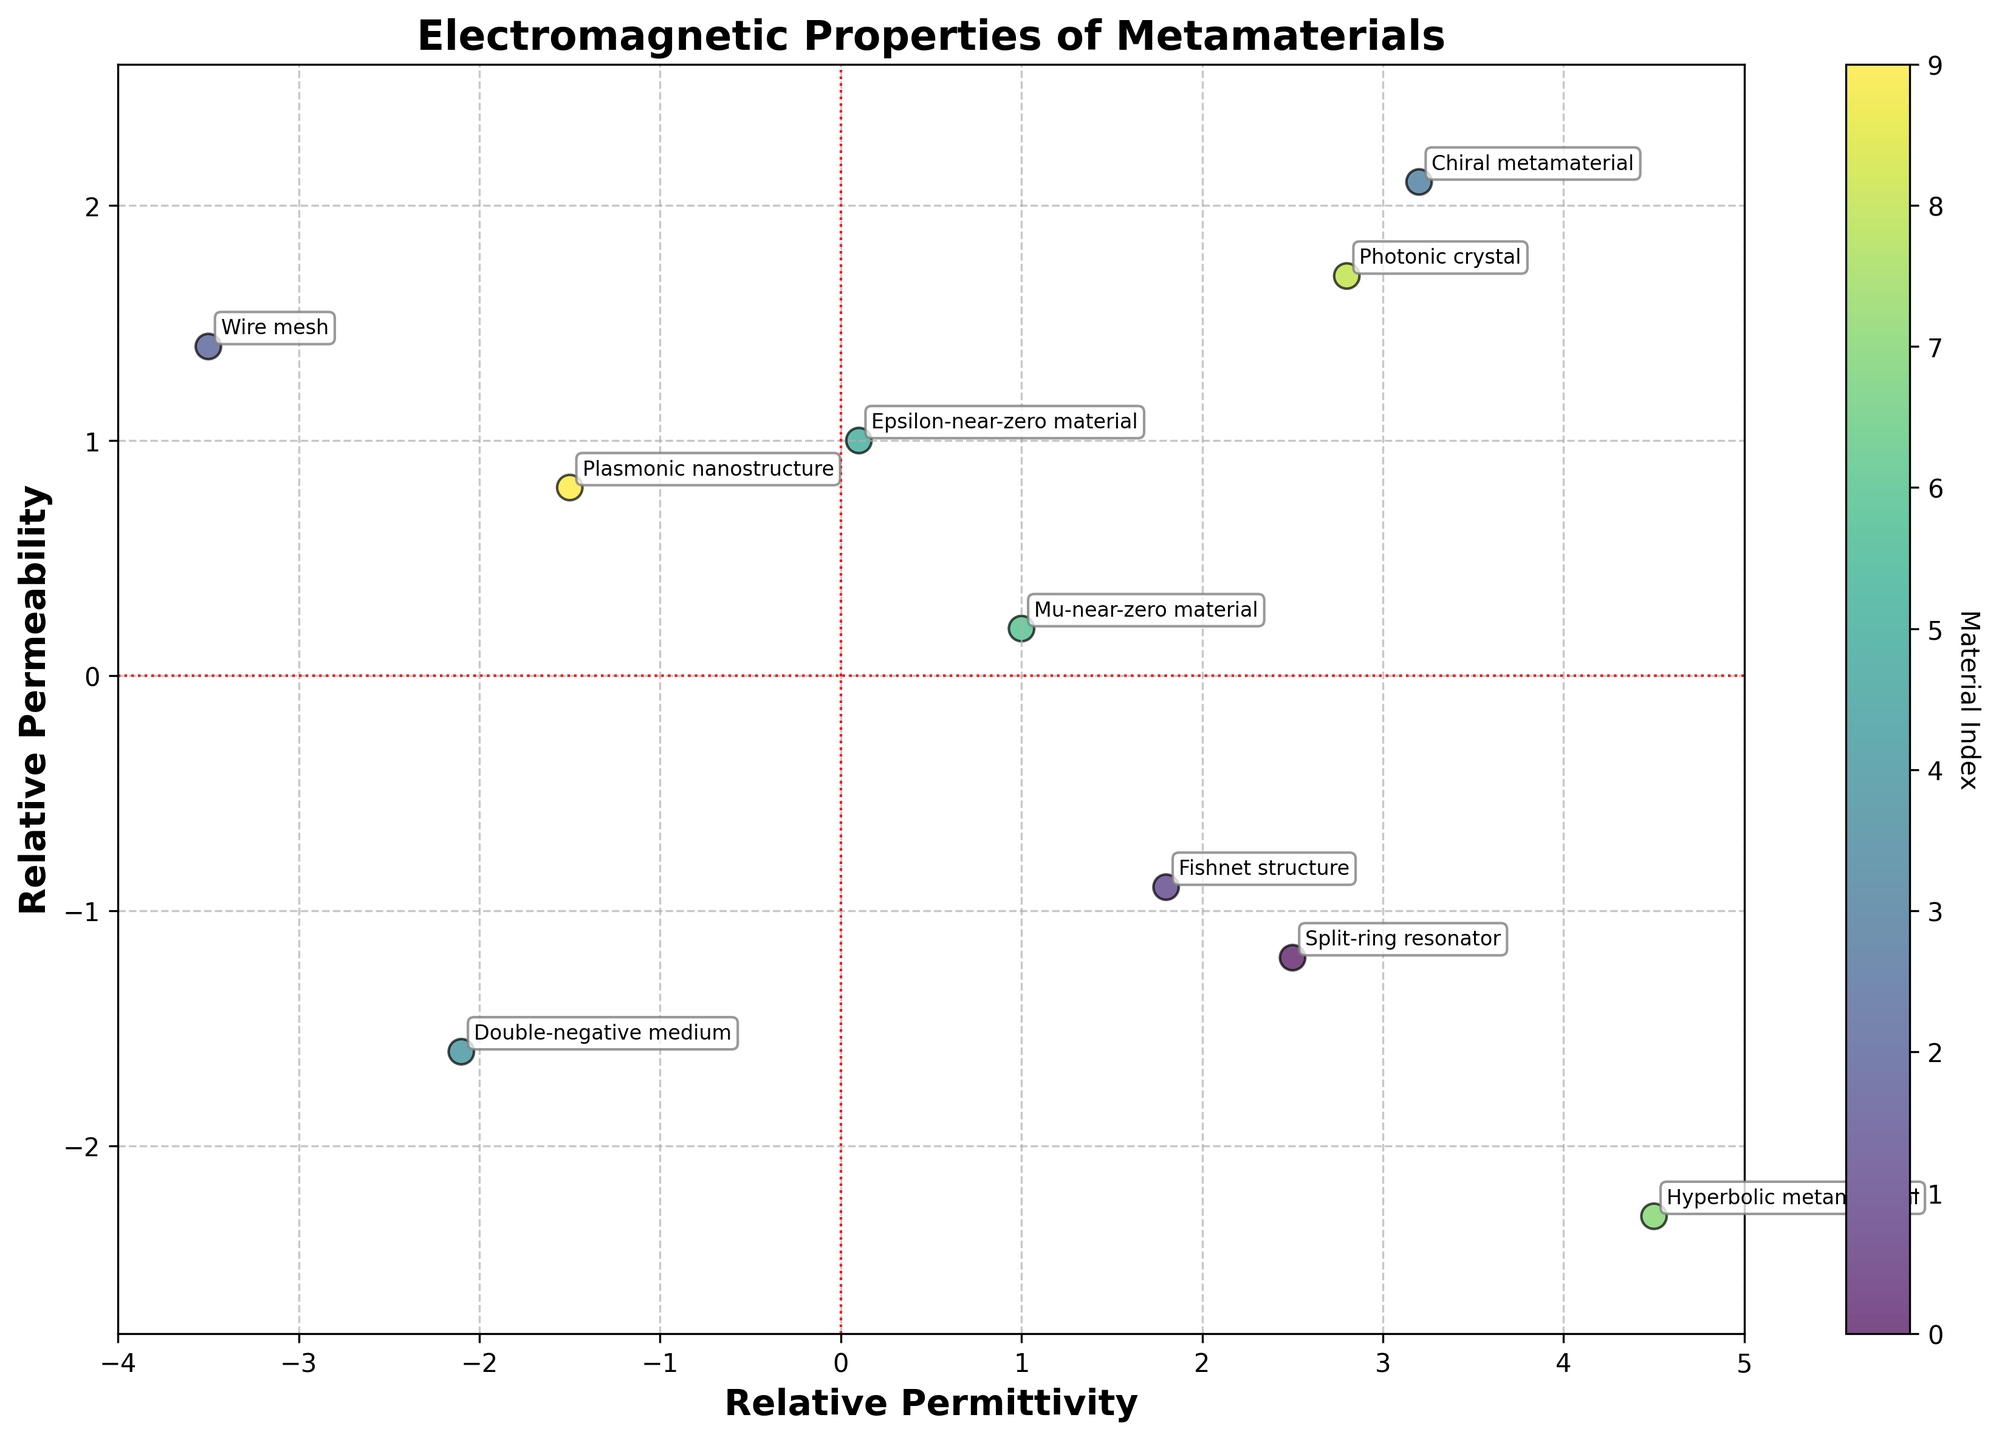What is the title of the plot? The title text is at the top of the biplot and generally provides an overview of what the data represents. Here, it explains the focus.
Answer: Electromagnetic Properties of Metamaterials How many different materials are plotted? Each labeled point on the biplot represents one material. By counting the number of distinct labels or points on the plot, you can determine the total number.
Answer: 10 Which material has the highest relative permittivity? On the x-axis (representing relative permittivity), find the material that has the point farthest to the right.
Answer: Hyperbolic metamaterial Which material has the lowest relative permeability? On the y-axis (representing relative permeability), identify the material with the point lowest on the plot.
Answer: Hyperbolic metamaterial How many materials have negative values for both relative permittivity and relative permeability? Identify points that are located in the bottom-left quadrant of the plot, indicating negative values for both properties. Count these points.
Answer: 2 Which materials have a relative permittivity less than zero? Locate points on the x-axis that are negative and list the materials corresponding to these points.
Answer: Wire mesh, Double-negative medium, Plasmonic nanostructure How many materials have positive relative permittivity and negative relative permeability? Look for points in the plot where x-values are positive and y-values are negative, representing materials with these characteristics. Count the number of such points.
Answer: 3 What is the relationship between the permittivity and permeability of the Epsilon-near-zero material and Mu-near-zero material? Compare the x and y values (relative permittivity and permeability) of both points directly by locating them on the plot.
Answer: Epsilon-near-zero material has lower permittivity but higher permeability than Mu-near-zero material Which material has the highest combined absolute values of relative permittivity and permeability? For each material, sum the absolute values of their relative permittivity and permeability. Identify the material with the highest total.
Answer: Hyperbolic metamaterial How does the permittivity of the photonic crystal compare to the permittivity of the chiral metamaterial? Locate both materials on the x-axis. Compare their x-values by looking at their relative positions on the x-axis.
Answer: Photonic crystal has lower permittivity than chiral metamaterial 